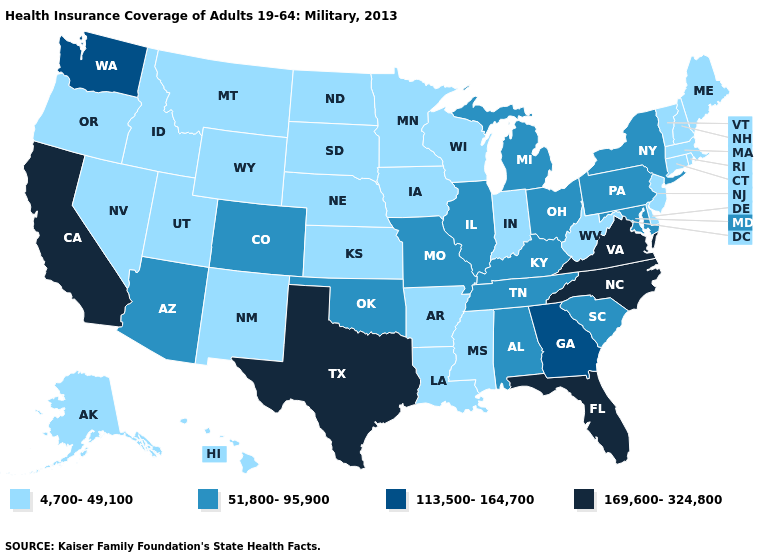What is the lowest value in the South?
Concise answer only. 4,700-49,100. What is the value of Nebraska?
Short answer required. 4,700-49,100. Does the map have missing data?
Be succinct. No. Which states have the lowest value in the West?
Concise answer only. Alaska, Hawaii, Idaho, Montana, Nevada, New Mexico, Oregon, Utah, Wyoming. Does New York have the lowest value in the USA?
Give a very brief answer. No. What is the value of Kansas?
Write a very short answer. 4,700-49,100. Does Nebraska have a lower value than Maine?
Concise answer only. No. Among the states that border Missouri , which have the lowest value?
Answer briefly. Arkansas, Iowa, Kansas, Nebraska. Among the states that border North Carolina , which have the highest value?
Concise answer only. Virginia. Name the states that have a value in the range 51,800-95,900?
Short answer required. Alabama, Arizona, Colorado, Illinois, Kentucky, Maryland, Michigan, Missouri, New York, Ohio, Oklahoma, Pennsylvania, South Carolina, Tennessee. What is the highest value in states that border New York?
Keep it brief. 51,800-95,900. Does Texas have a higher value than Florida?
Write a very short answer. No. What is the highest value in states that border Maryland?
Write a very short answer. 169,600-324,800. Name the states that have a value in the range 113,500-164,700?
Keep it brief. Georgia, Washington. What is the value of Nevada?
Write a very short answer. 4,700-49,100. 